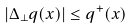<formula> <loc_0><loc_0><loc_500><loc_500>| \Delta _ { \perp } q ( x ) | \leq q ^ { + } ( x )</formula> 